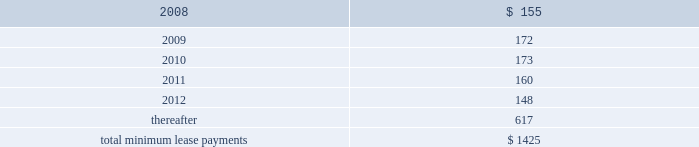Notes to consolidated financial statements ( continued ) note 8 2014commitments and contingencies ( continued ) provide renewal options for terms of 3 to 7 additional years .
Leases for retail space are for terms of 5 to 20 years , the majority of which are for 10 years , and often contain multi-year renewal options .
As of september 29 , 2007 , the company 2019s total future minimum lease payments under noncancelable operating leases were $ 1.4 billion , of which $ 1.1 billion related to leases for retail space .
Rent expense under all operating leases , including both cancelable and noncancelable leases , was $ 151 million , $ 138 million , and $ 140 million in 2007 , 2006 , and 2005 , respectively .
Future minimum lease payments under noncancelable operating leases having remaining terms in excess of one year as of september 29 , 2007 , are as follows ( in millions ) : fiscal years .
Accrued warranty and indemnifications the company offers a basic limited parts and labor warranty on its hardware products .
The basic warranty period for hardware products is typically one year from the date of purchase by the end-user .
The company also offers a 90-day basic warranty for its service parts used to repair the company 2019s hardware products .
The company provides currently for the estimated cost that may be incurred under its basic limited product warranties at the time related revenue is recognized .
Factors considered in determining appropriate accruals for product warranty obligations include the size of the installed base of products subject to warranty protection , historical and projected warranty claim rates , historical and projected cost-per-claim , and knowledge of specific product failures that are outside of the company 2019s typical experience .
The company assesses the adequacy of its preexisting warranty liabilities and adjusts the amounts as necessary based on actual experience and changes in future estimates .
For products accounted for under subscription accounting pursuant to sop no .
97-2 , the company recognizes warranty expense as incurred .
The company periodically provides updates to its applications and system software to maintain the software 2019s compliance with specifications .
The estimated cost to develop such updates is accounted for as warranty costs that are recognized at the time related software revenue is recognized .
Factors considered in determining appropriate accruals related to such updates include the number of units delivered , the number of updates expected to occur , and the historical cost and estimated future cost of the resources necessary to develop these updates. .
What is the range between the shortest and longest length of leases for retail space , in years? 
Computations: (20 - 5)
Answer: 15.0. 